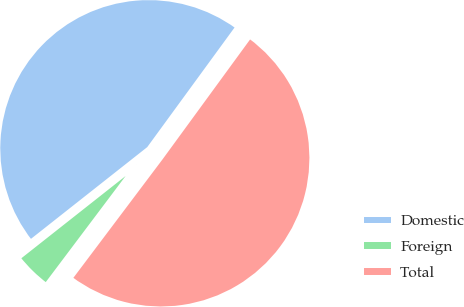Convert chart to OTSL. <chart><loc_0><loc_0><loc_500><loc_500><pie_chart><fcel>Domestic<fcel>Foreign<fcel>Total<nl><fcel>45.67%<fcel>4.1%<fcel>50.23%<nl></chart> 